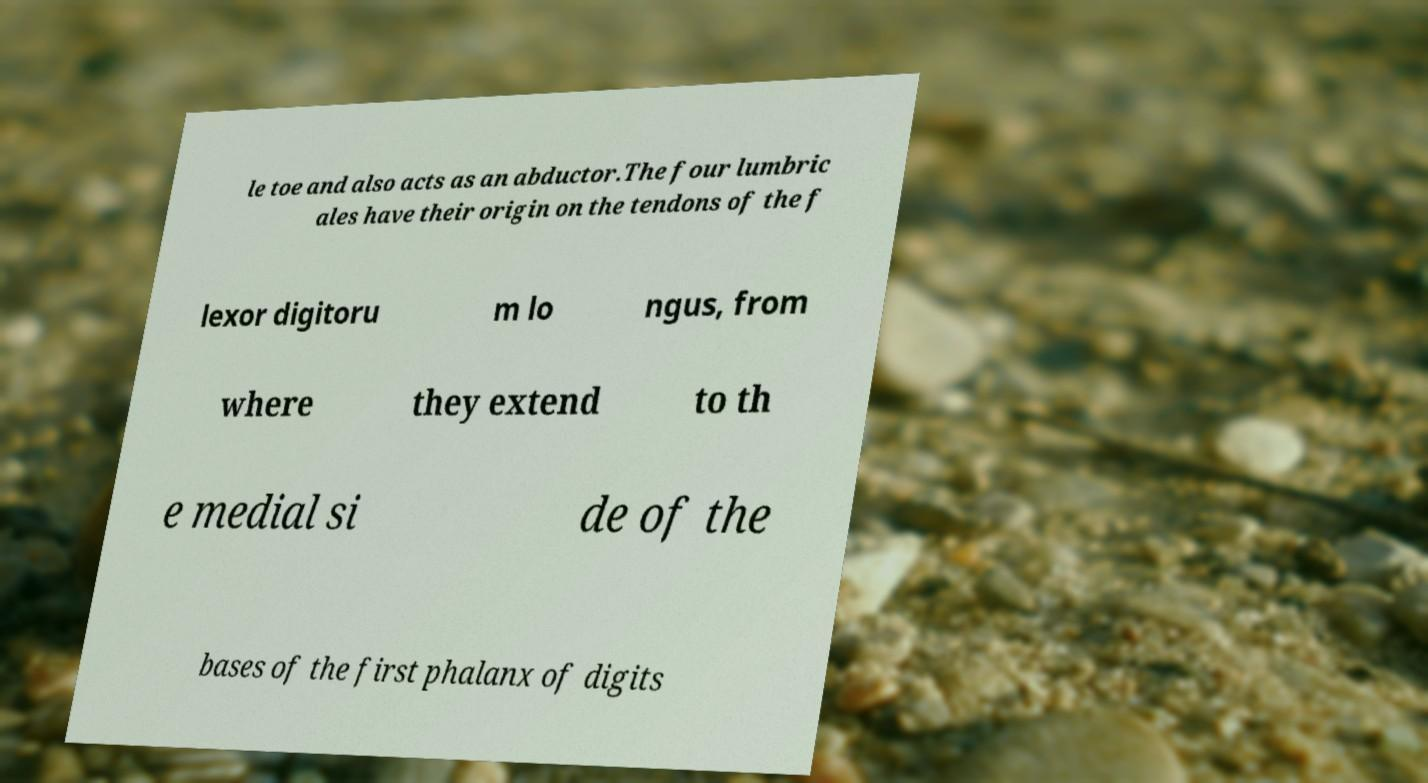There's text embedded in this image that I need extracted. Can you transcribe it verbatim? le toe and also acts as an abductor.The four lumbric ales have their origin on the tendons of the f lexor digitoru m lo ngus, from where they extend to th e medial si de of the bases of the first phalanx of digits 